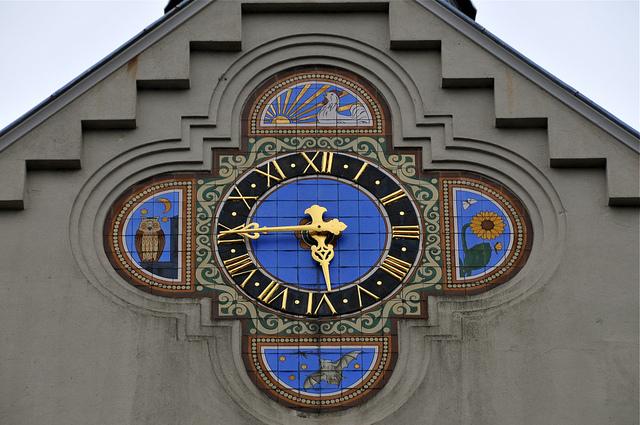Is the number of the clock in Roman numeral?
Keep it brief. Yes. What color are the flowers?
Be succinct. Yellow. What animal is the short hand pointing to?
Short answer required. Bat. Is this at the stadium?
Give a very brief answer. No. What time is shown?
Keep it brief. 5:45. What time is it?
Short answer required. 5:45. What is the wall made of?
Give a very brief answer. Concrete. 